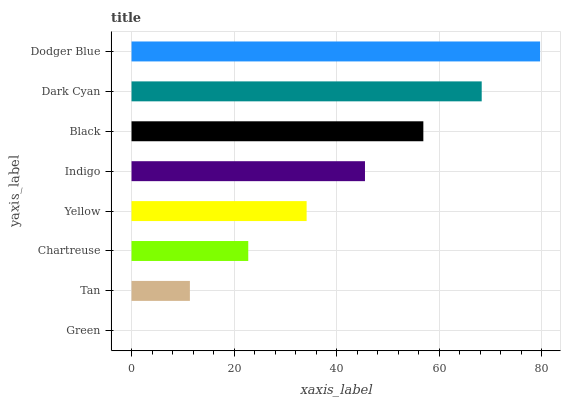Is Green the minimum?
Answer yes or no. Yes. Is Dodger Blue the maximum?
Answer yes or no. Yes. Is Tan the minimum?
Answer yes or no. No. Is Tan the maximum?
Answer yes or no. No. Is Tan greater than Green?
Answer yes or no. Yes. Is Green less than Tan?
Answer yes or no. Yes. Is Green greater than Tan?
Answer yes or no. No. Is Tan less than Green?
Answer yes or no. No. Is Indigo the high median?
Answer yes or no. Yes. Is Yellow the low median?
Answer yes or no. Yes. Is Dark Cyan the high median?
Answer yes or no. No. Is Dark Cyan the low median?
Answer yes or no. No. 